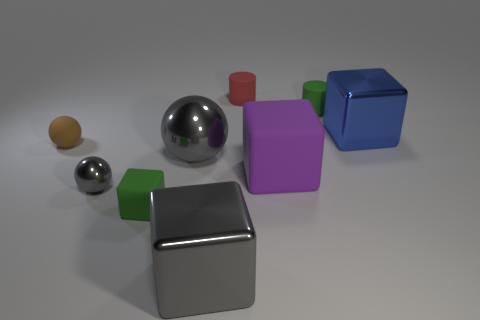Add 1 large blue metallic cubes. How many objects exist? 10 Subtract all spheres. How many objects are left? 6 Subtract 0 brown blocks. How many objects are left? 9 Subtract all small brown matte balls. Subtract all tiny gray metallic balls. How many objects are left? 7 Add 1 green rubber objects. How many green rubber objects are left? 3 Add 2 gray cubes. How many gray cubes exist? 3 